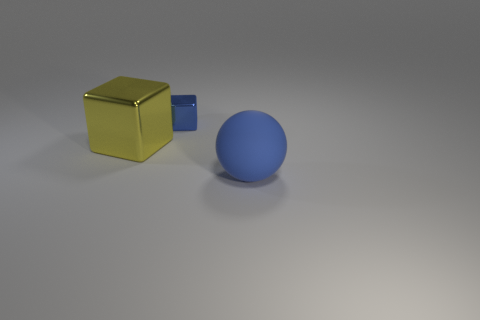Subtract all cubes. How many objects are left? 1 Add 2 tiny metal cubes. How many objects exist? 5 Subtract all blue cubes. How many cubes are left? 1 Subtract all gray blocks. Subtract all blue balls. How many blocks are left? 2 Subtract all cyan cylinders. How many blue blocks are left? 1 Subtract all small purple rubber spheres. Subtract all big yellow metallic blocks. How many objects are left? 2 Add 2 big blue matte things. How many big blue matte things are left? 3 Add 1 red matte spheres. How many red matte spheres exist? 1 Subtract 0 brown spheres. How many objects are left? 3 Subtract 2 blocks. How many blocks are left? 0 